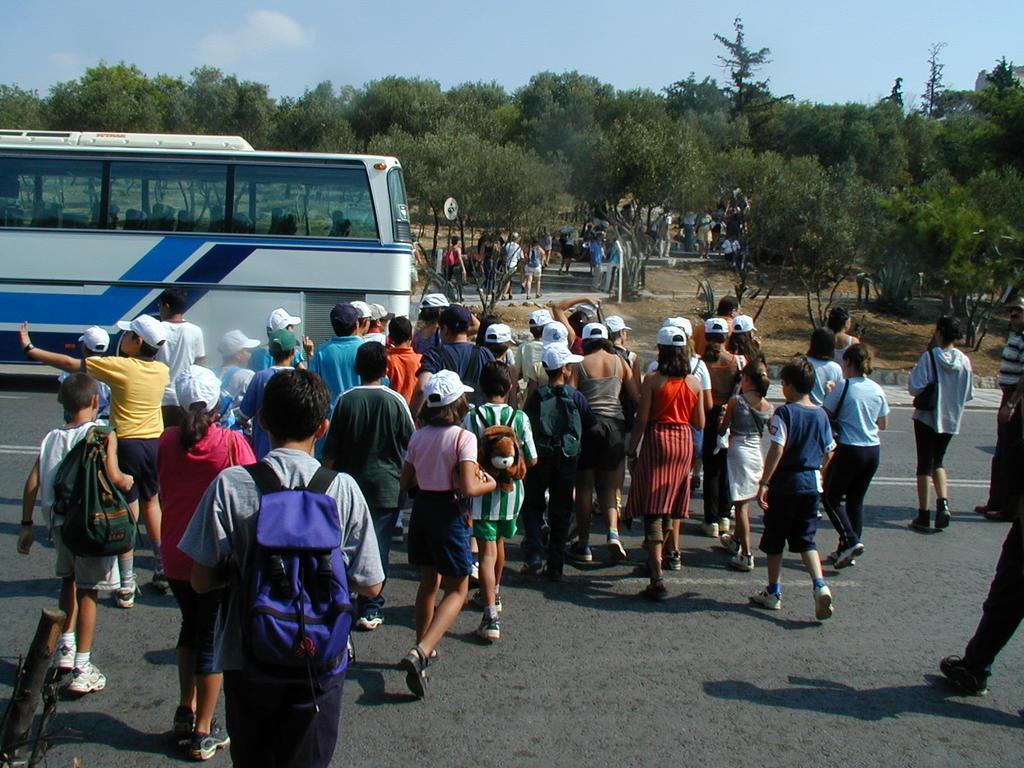Please provide a concise description of this image. In this picture we can see group of people and few people carrying backpacks, on the left side of the image we can see a bus on the road, in the background we can find few trees and clouds. 